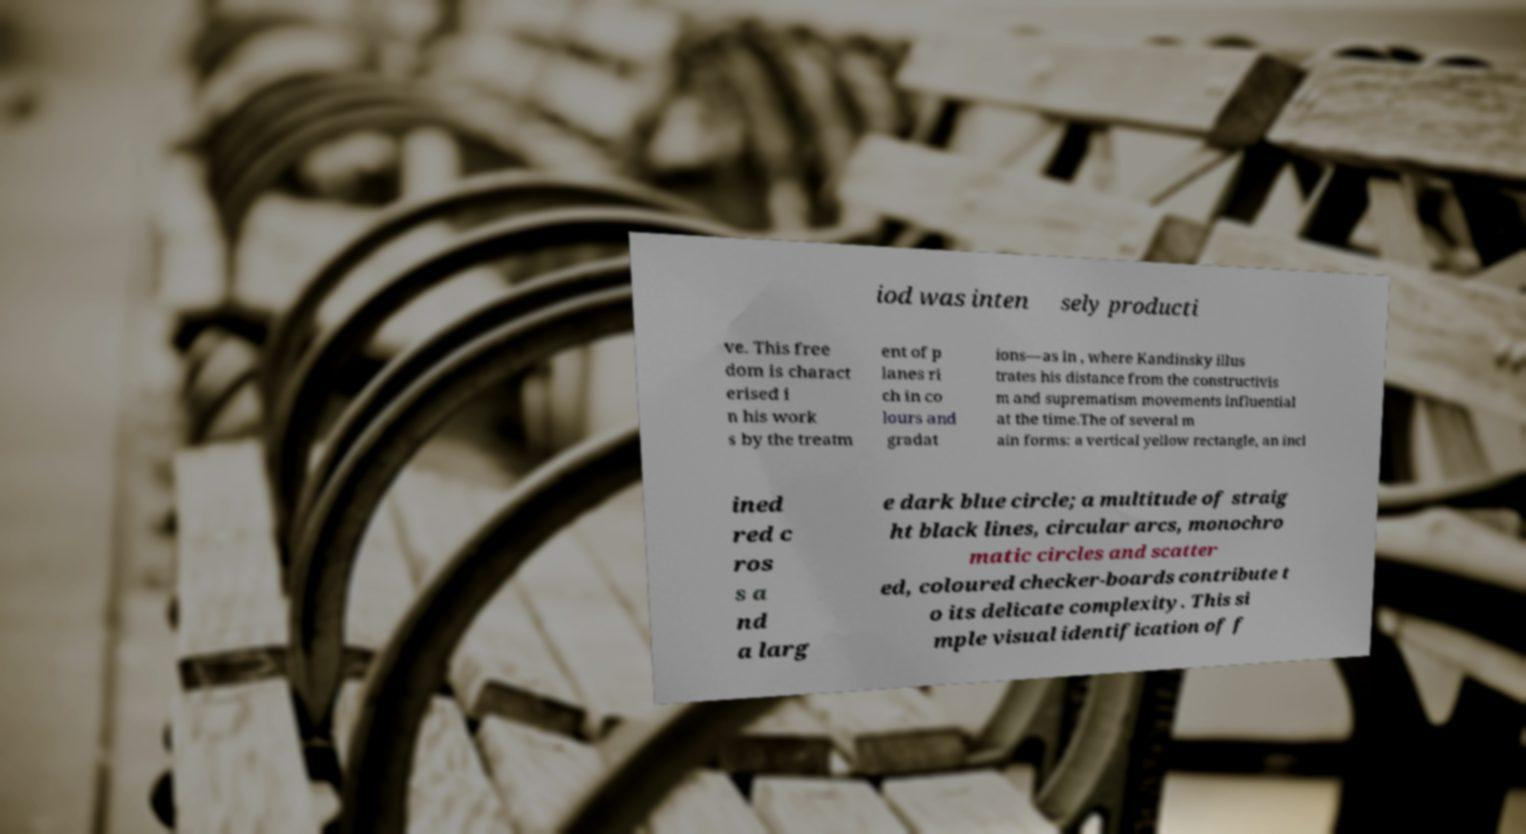Could you assist in decoding the text presented in this image and type it out clearly? iod was inten sely producti ve. This free dom is charact erised i n his work s by the treatm ent of p lanes ri ch in co lours and gradat ions—as in , where Kandinsky illus trates his distance from the constructivis m and suprematism movements influential at the time.The of several m ain forms: a vertical yellow rectangle, an incl ined red c ros s a nd a larg e dark blue circle; a multitude of straig ht black lines, circular arcs, monochro matic circles and scatter ed, coloured checker-boards contribute t o its delicate complexity. This si mple visual identification of f 